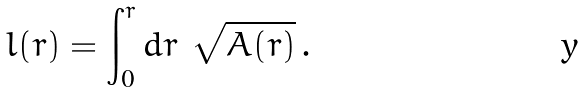<formula> <loc_0><loc_0><loc_500><loc_500>l ( r ) = \int _ { 0 } ^ { r } d r \ \sqrt { A ( r ) } \, .</formula> 